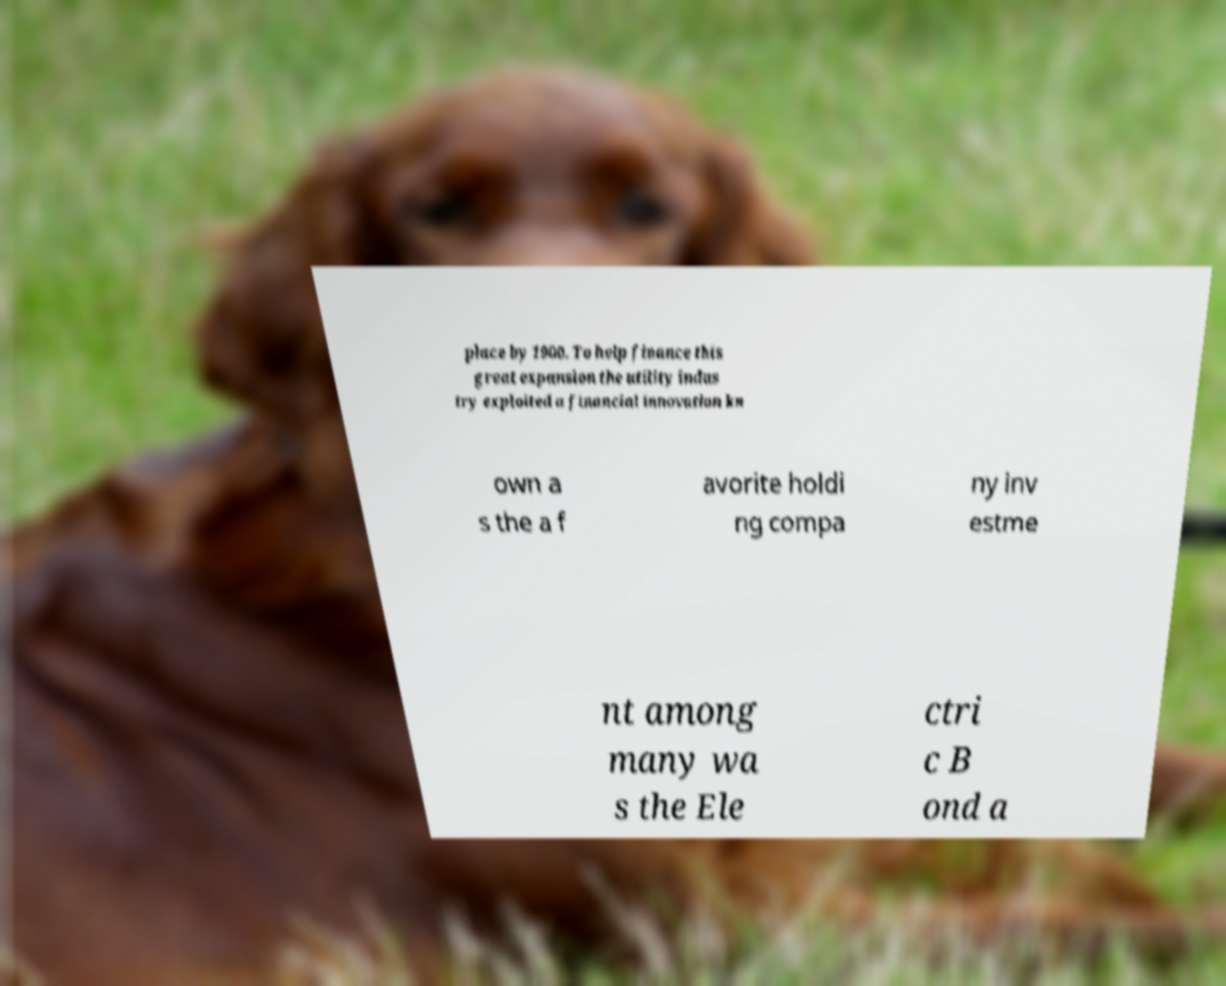Can you read and provide the text displayed in the image?This photo seems to have some interesting text. Can you extract and type it out for me? place by 1900. To help finance this great expansion the utility indus try exploited a financial innovation kn own a s the a f avorite holdi ng compa ny inv estme nt among many wa s the Ele ctri c B ond a 